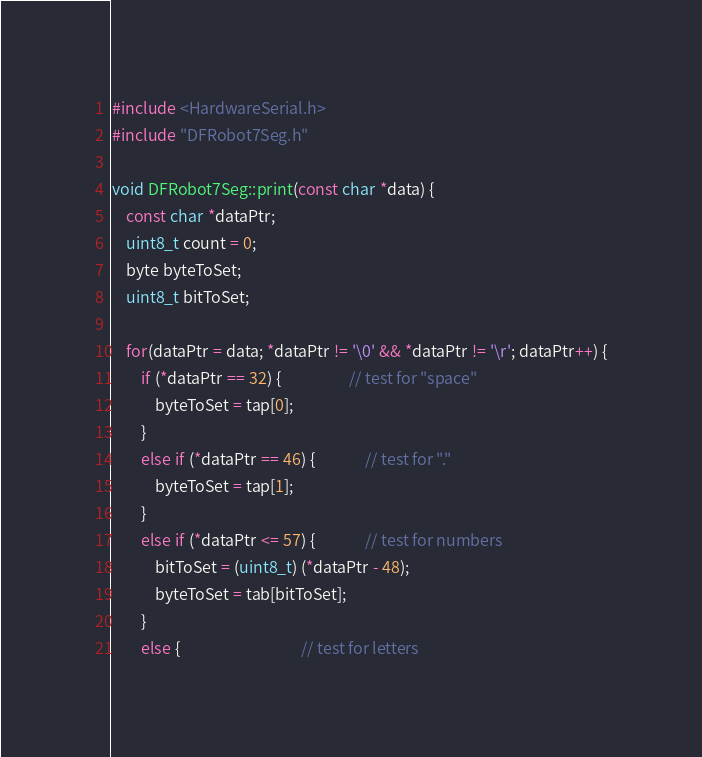<code> <loc_0><loc_0><loc_500><loc_500><_C++_>#include <HardwareSerial.h>
#include "DFRobot7Seg.h"

void DFRobot7Seg::print(const char *data) {
    const char *dataPtr;
    uint8_t count = 0;
    byte byteToSet;
    uint8_t bitToSet;

    for(dataPtr = data; *dataPtr != '\0' && *dataPtr != '\r'; dataPtr++) {
        if (*dataPtr == 32) {                   // test for "space"
            byteToSet = tap[0];
        }
        else if (*dataPtr == 46) {              // test for "."
            byteToSet = tap[1];
        }
        else if (*dataPtr <= 57) {              // test for numbers
            bitToSet = (uint8_t) (*dataPtr - 48);
            byteToSet = tab[bitToSet];
        }
        else {                                  // test for letters</code> 